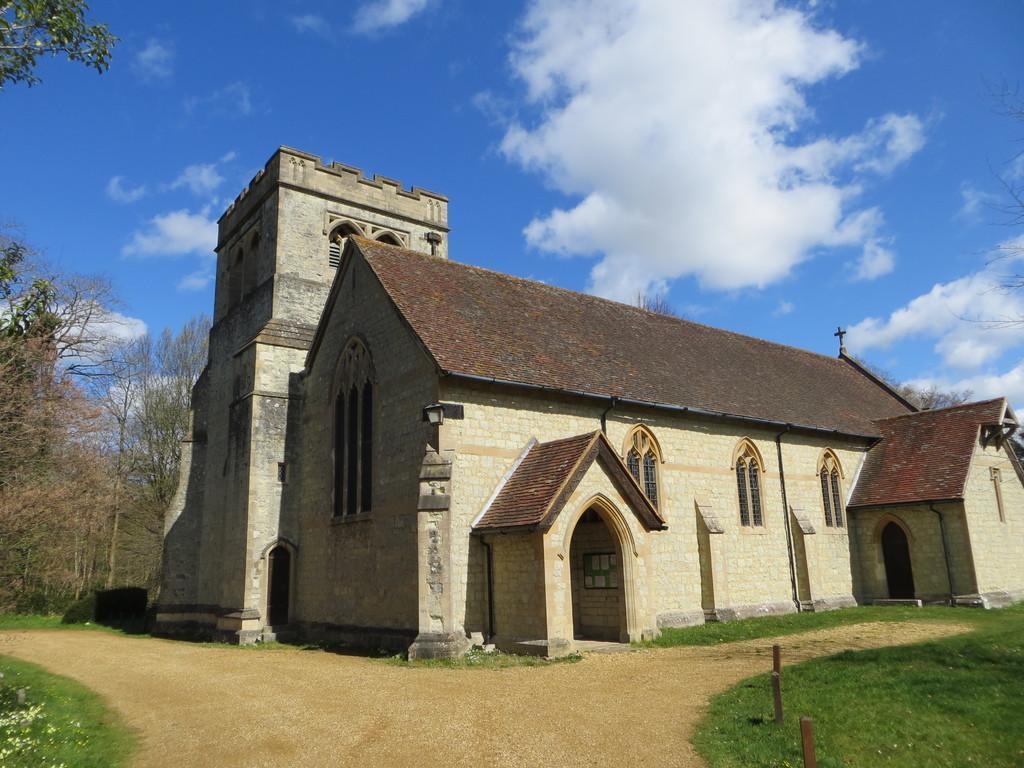Please provide a concise description of this image. In this picture I can see a building and few trees. I can see grass on the ground and a blue cloudy sky. 